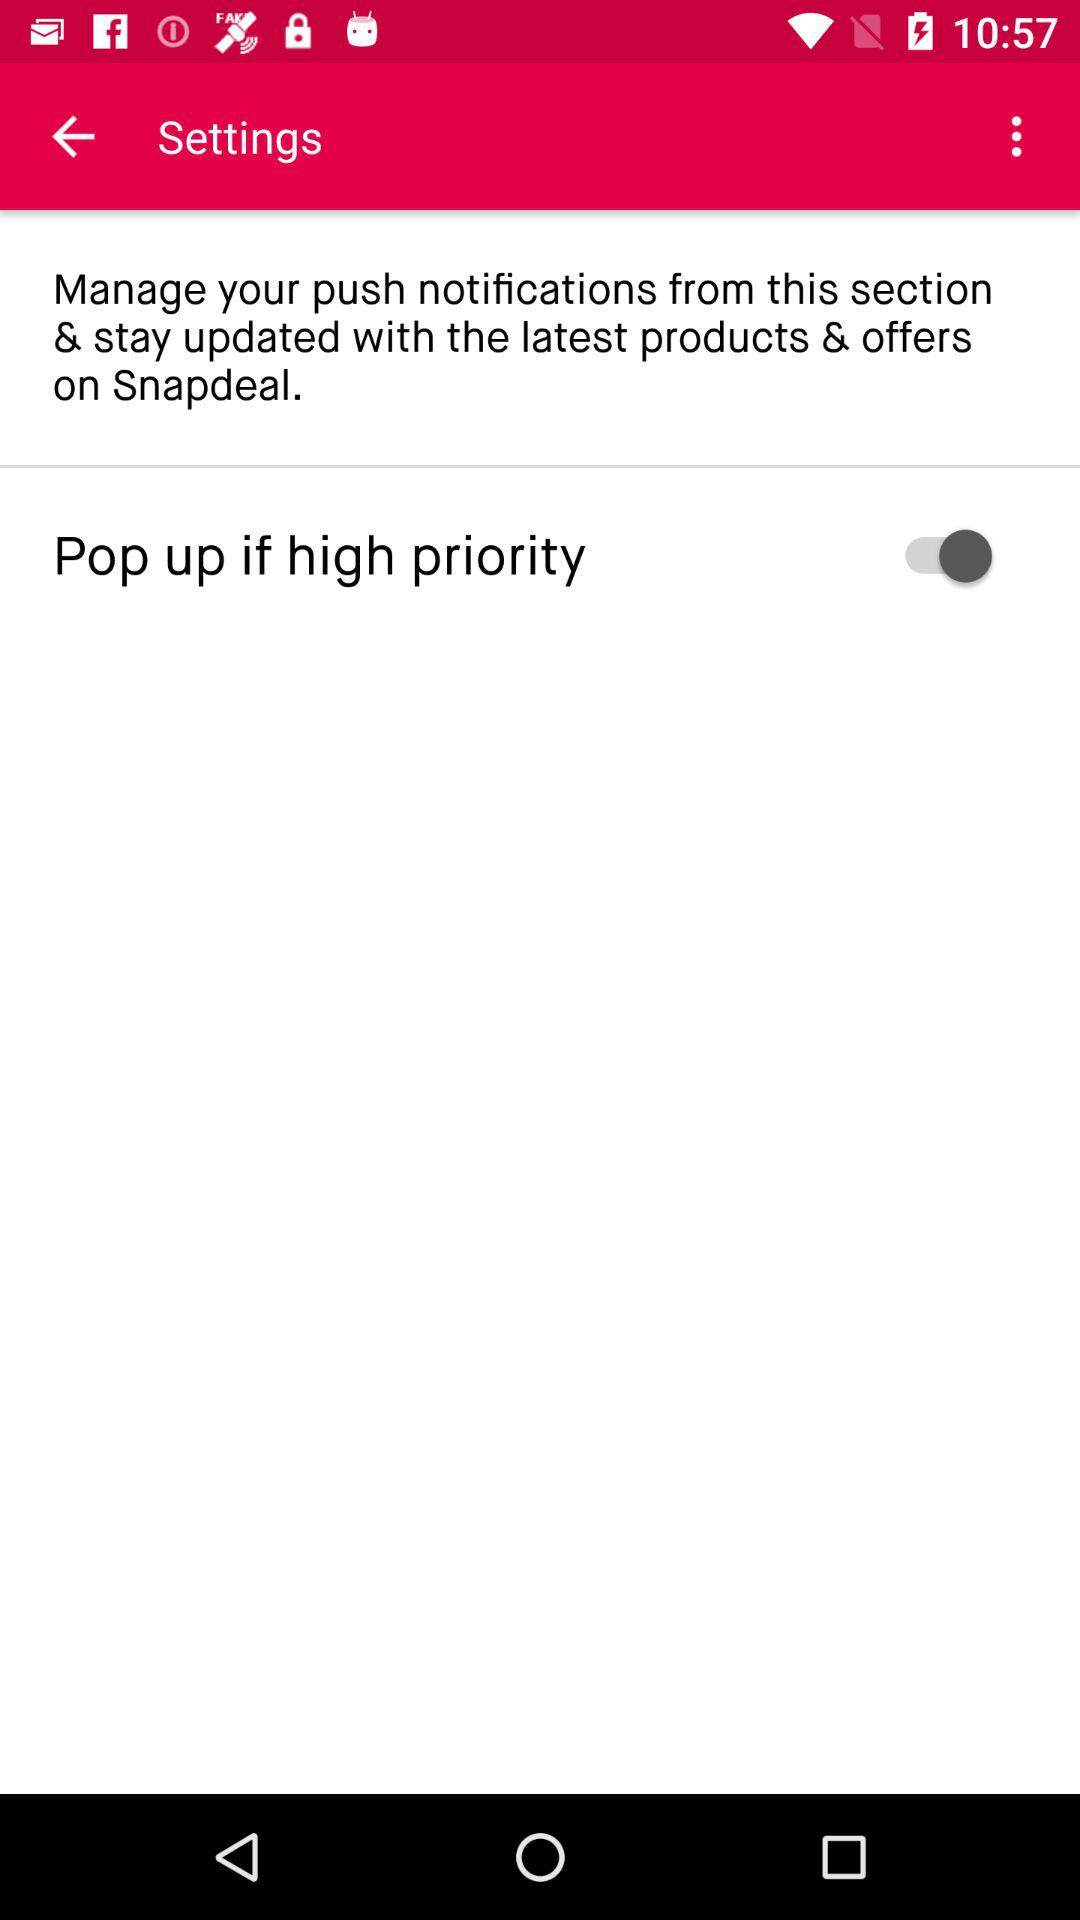What is the user's name?
When the provided information is insufficient, respond with <no answer>. <no answer> 